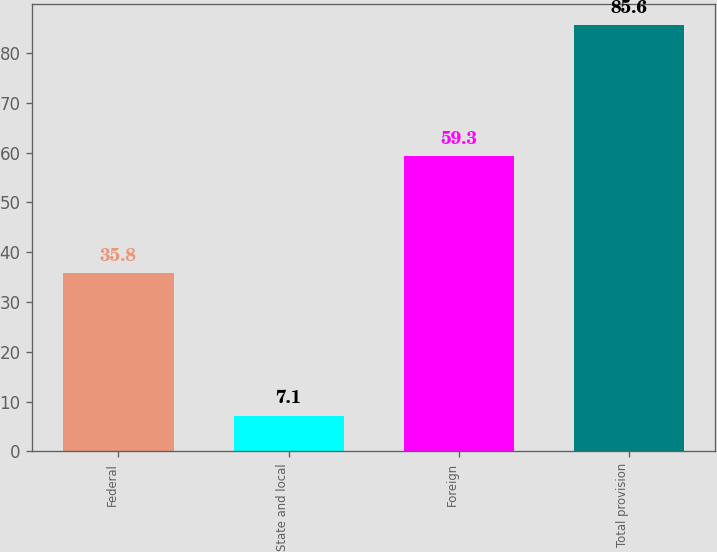Convert chart. <chart><loc_0><loc_0><loc_500><loc_500><bar_chart><fcel>Federal<fcel>State and local<fcel>Foreign<fcel>Total provision<nl><fcel>35.8<fcel>7.1<fcel>59.3<fcel>85.6<nl></chart> 